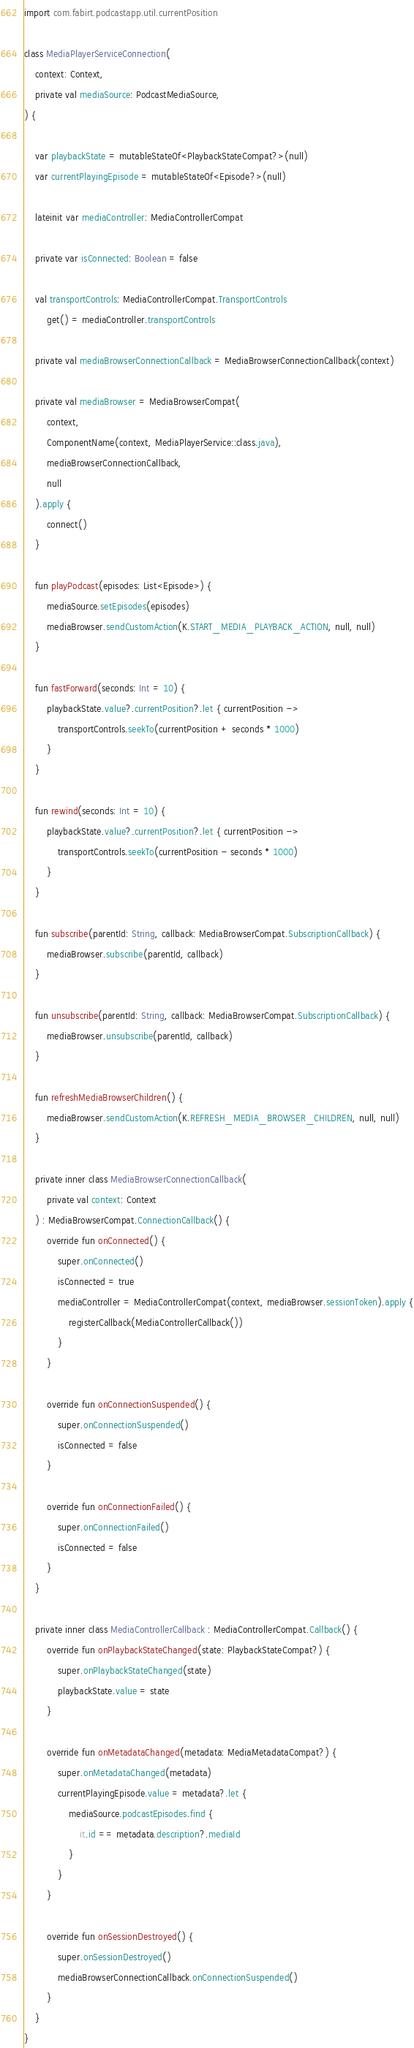<code> <loc_0><loc_0><loc_500><loc_500><_Kotlin_>import com.fabirt.podcastapp.util.currentPosition

class MediaPlayerServiceConnection(
    context: Context,
    private val mediaSource: PodcastMediaSource,
) {

    var playbackState = mutableStateOf<PlaybackStateCompat?>(null)
    var currentPlayingEpisode = mutableStateOf<Episode?>(null)

    lateinit var mediaController: MediaControllerCompat

    private var isConnected: Boolean = false

    val transportControls: MediaControllerCompat.TransportControls
        get() = mediaController.transportControls

    private val mediaBrowserConnectionCallback = MediaBrowserConnectionCallback(context)

    private val mediaBrowser = MediaBrowserCompat(
        context,
        ComponentName(context, MediaPlayerService::class.java),
        mediaBrowserConnectionCallback,
        null
    ).apply {
        connect()
    }

    fun playPodcast(episodes: List<Episode>) {
        mediaSource.setEpisodes(episodes)
        mediaBrowser.sendCustomAction(K.START_MEDIA_PLAYBACK_ACTION, null, null)
    }

    fun fastForward(seconds: Int = 10) {
        playbackState.value?.currentPosition?.let { currentPosition ->
            transportControls.seekTo(currentPosition + seconds * 1000)
        }
    }

    fun rewind(seconds: Int = 10) {
        playbackState.value?.currentPosition?.let { currentPosition ->
            transportControls.seekTo(currentPosition - seconds * 1000)
        }
    }

    fun subscribe(parentId: String, callback: MediaBrowserCompat.SubscriptionCallback) {
        mediaBrowser.subscribe(parentId, callback)
    }

    fun unsubscribe(parentId: String, callback: MediaBrowserCompat.SubscriptionCallback) {
        mediaBrowser.unsubscribe(parentId, callback)
    }

    fun refreshMediaBrowserChildren() {
        mediaBrowser.sendCustomAction(K.REFRESH_MEDIA_BROWSER_CHILDREN, null, null)
    }

    private inner class MediaBrowserConnectionCallback(
        private val context: Context
    ) : MediaBrowserCompat.ConnectionCallback() {
        override fun onConnected() {
            super.onConnected()
            isConnected = true
            mediaController = MediaControllerCompat(context, mediaBrowser.sessionToken).apply {
                registerCallback(MediaControllerCallback())
            }
        }

        override fun onConnectionSuspended() {
            super.onConnectionSuspended()
            isConnected = false
        }

        override fun onConnectionFailed() {
            super.onConnectionFailed()
            isConnected = false
        }
    }

    private inner class MediaControllerCallback : MediaControllerCompat.Callback() {
        override fun onPlaybackStateChanged(state: PlaybackStateCompat?) {
            super.onPlaybackStateChanged(state)
            playbackState.value = state
        }

        override fun onMetadataChanged(metadata: MediaMetadataCompat?) {
            super.onMetadataChanged(metadata)
            currentPlayingEpisode.value = metadata?.let {
                mediaSource.podcastEpisodes.find {
                    it.id == metadata.description?.mediaId
                }
            }
        }

        override fun onSessionDestroyed() {
            super.onSessionDestroyed()
            mediaBrowserConnectionCallback.onConnectionSuspended()
        }
    }
}</code> 